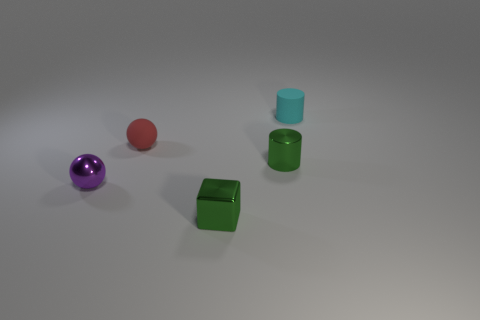Add 2 cyan things. How many objects exist? 7 Subtract all small cyan things. Subtract all big green metal objects. How many objects are left? 4 Add 2 balls. How many balls are left? 4 Add 1 blue metal balls. How many blue metal balls exist? 1 Subtract 1 green blocks. How many objects are left? 4 Subtract all cubes. How many objects are left? 4 Subtract 1 cubes. How many cubes are left? 0 Subtract all blue balls. Subtract all green cylinders. How many balls are left? 2 Subtract all purple spheres. How many cyan cylinders are left? 1 